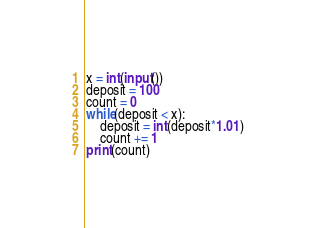<code> <loc_0><loc_0><loc_500><loc_500><_Python_>x = int(input())
deposit = 100
count = 0
while(deposit < x):
    deposit = int(deposit*1.01)
    count += 1
print(count)</code> 